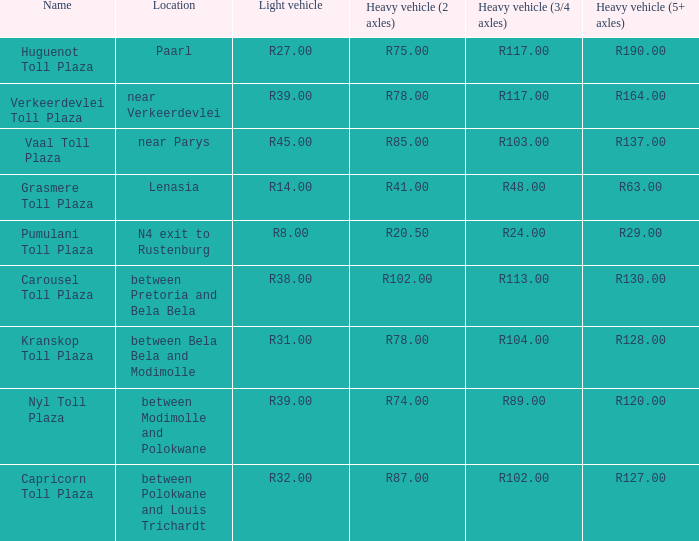00? Capricorn Toll Plaza. 